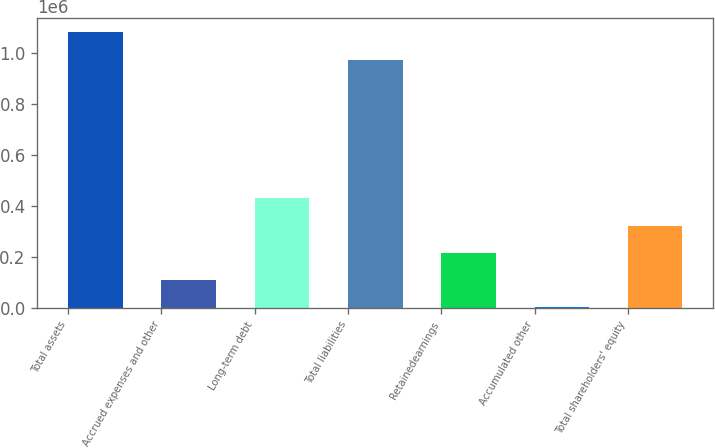Convert chart. <chart><loc_0><loc_0><loc_500><loc_500><bar_chart><fcel>Total assets<fcel>Accrued expenses and other<fcel>Long-term debt<fcel>Total liabilities<fcel>Retainedearnings<fcel>Accumulated other<fcel>Total shareholders' equity<nl><fcel>1.08117e+06<fcel>109806<fcel>430804<fcel>974168<fcel>216805<fcel>2806<fcel>323805<nl></chart> 